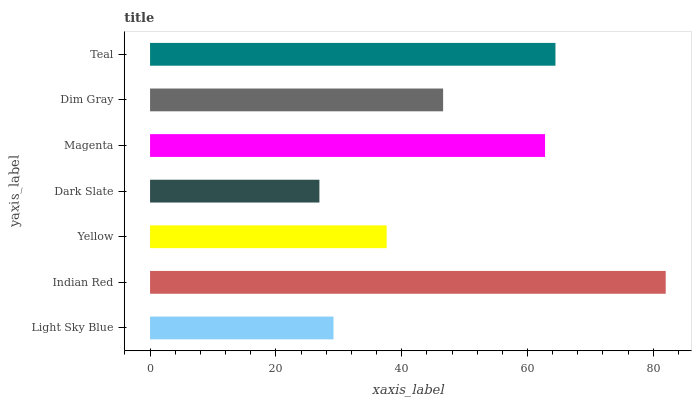Is Dark Slate the minimum?
Answer yes or no. Yes. Is Indian Red the maximum?
Answer yes or no. Yes. Is Yellow the minimum?
Answer yes or no. No. Is Yellow the maximum?
Answer yes or no. No. Is Indian Red greater than Yellow?
Answer yes or no. Yes. Is Yellow less than Indian Red?
Answer yes or no. Yes. Is Yellow greater than Indian Red?
Answer yes or no. No. Is Indian Red less than Yellow?
Answer yes or no. No. Is Dim Gray the high median?
Answer yes or no. Yes. Is Dim Gray the low median?
Answer yes or no. Yes. Is Dark Slate the high median?
Answer yes or no. No. Is Magenta the low median?
Answer yes or no. No. 